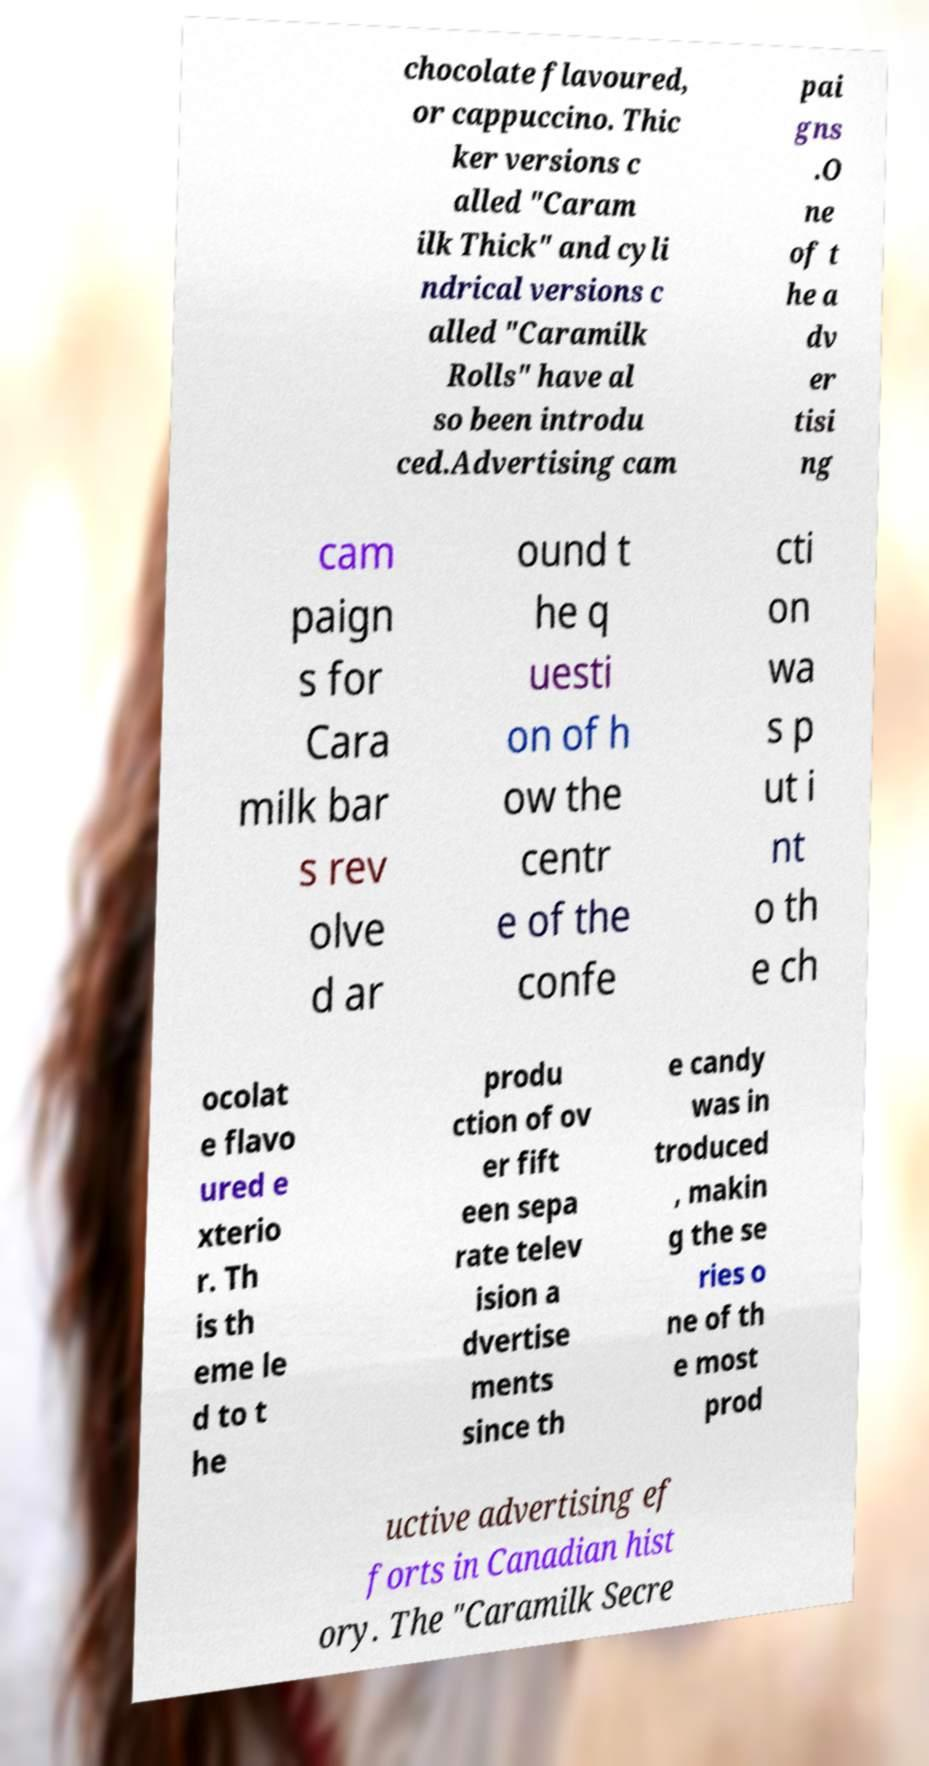There's text embedded in this image that I need extracted. Can you transcribe it verbatim? chocolate flavoured, or cappuccino. Thic ker versions c alled "Caram ilk Thick" and cyli ndrical versions c alled "Caramilk Rolls" have al so been introdu ced.Advertising cam pai gns .O ne of t he a dv er tisi ng cam paign s for Cara milk bar s rev olve d ar ound t he q uesti on of h ow the centr e of the confe cti on wa s p ut i nt o th e ch ocolat e flavo ured e xterio r. Th is th eme le d to t he produ ction of ov er fift een sepa rate telev ision a dvertise ments since th e candy was in troduced , makin g the se ries o ne of th e most prod uctive advertising ef forts in Canadian hist ory. The "Caramilk Secre 